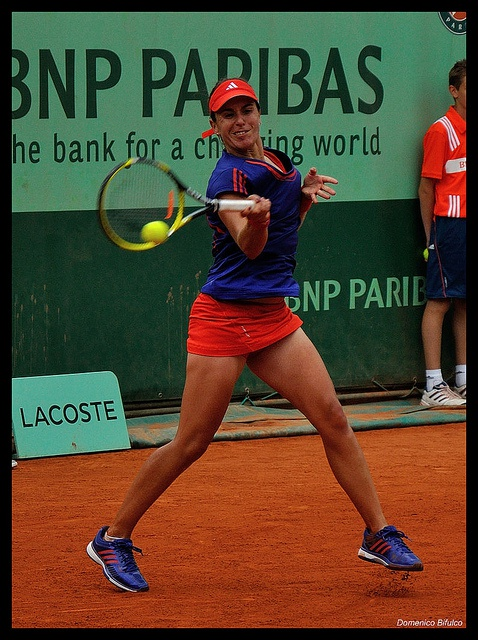Describe the objects in this image and their specific colors. I can see people in black, maroon, and brown tones, people in black, red, and maroon tones, tennis racket in black, teal, and darkgreen tones, sports ball in black, olive, yellow, and khaki tones, and sports ball in black, olive, and darkgreen tones in this image. 